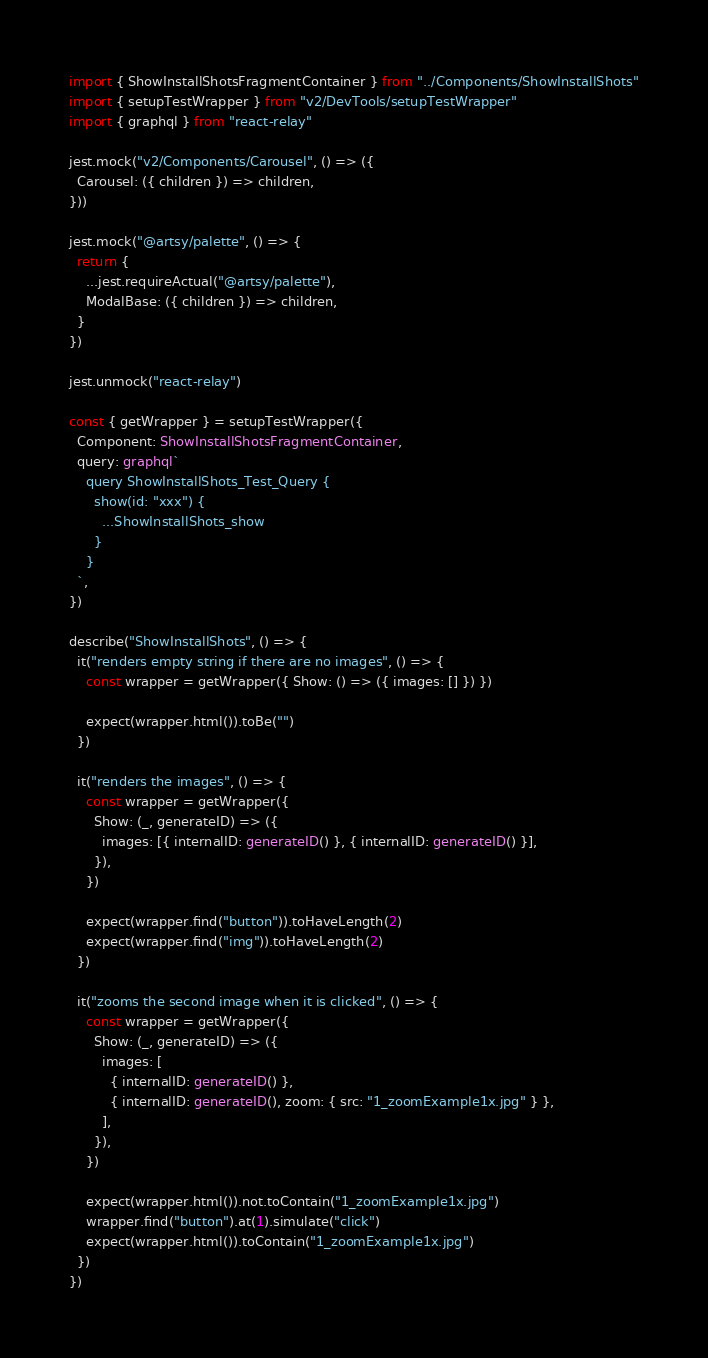Convert code to text. <code><loc_0><loc_0><loc_500><loc_500><_TypeScript_>import { ShowInstallShotsFragmentContainer } from "../Components/ShowInstallShots"
import { setupTestWrapper } from "v2/DevTools/setupTestWrapper"
import { graphql } from "react-relay"

jest.mock("v2/Components/Carousel", () => ({
  Carousel: ({ children }) => children,
}))

jest.mock("@artsy/palette", () => {
  return {
    ...jest.requireActual("@artsy/palette"),
    ModalBase: ({ children }) => children,
  }
})

jest.unmock("react-relay")

const { getWrapper } = setupTestWrapper({
  Component: ShowInstallShotsFragmentContainer,
  query: graphql`
    query ShowInstallShots_Test_Query {
      show(id: "xxx") {
        ...ShowInstallShots_show
      }
    }
  `,
})

describe("ShowInstallShots", () => {
  it("renders empty string if there are no images", () => {
    const wrapper = getWrapper({ Show: () => ({ images: [] }) })

    expect(wrapper.html()).toBe("")
  })

  it("renders the images", () => {
    const wrapper = getWrapper({
      Show: (_, generateID) => ({
        images: [{ internalID: generateID() }, { internalID: generateID() }],
      }),
    })

    expect(wrapper.find("button")).toHaveLength(2)
    expect(wrapper.find("img")).toHaveLength(2)
  })

  it("zooms the second image when it is clicked", () => {
    const wrapper = getWrapper({
      Show: (_, generateID) => ({
        images: [
          { internalID: generateID() },
          { internalID: generateID(), zoom: { src: "1_zoomExample1x.jpg" } },
        ],
      }),
    })

    expect(wrapper.html()).not.toContain("1_zoomExample1x.jpg")
    wrapper.find("button").at(1).simulate("click")
    expect(wrapper.html()).toContain("1_zoomExample1x.jpg")
  })
})
</code> 